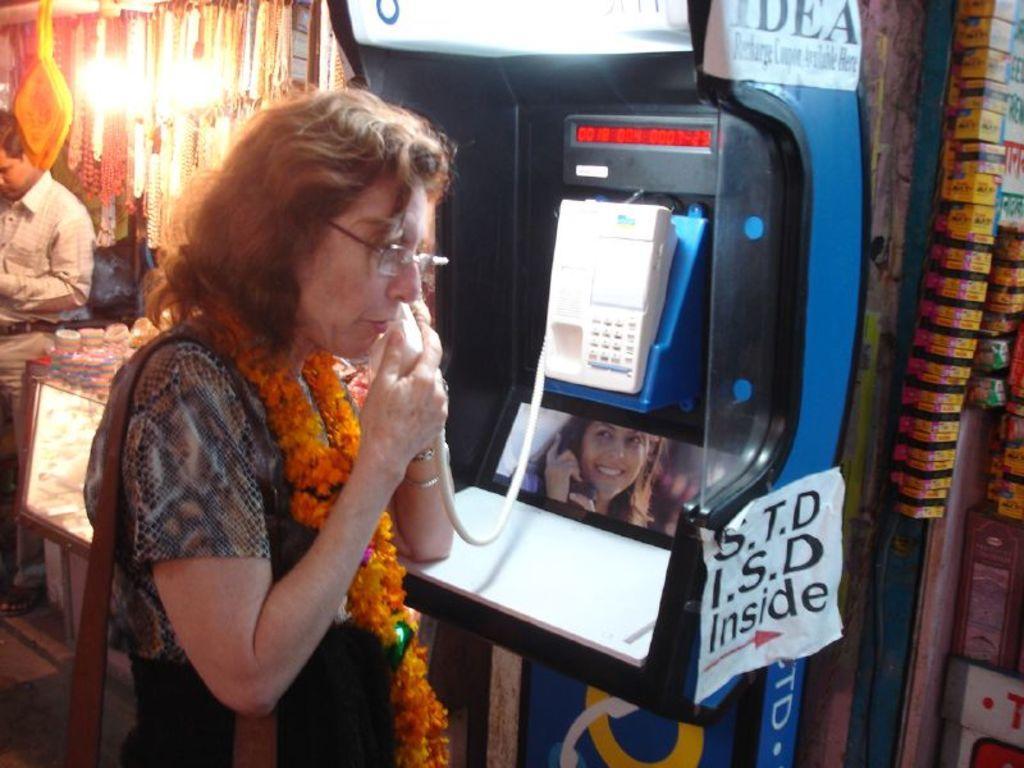Describe this image in one or two sentences. In this image there is a lady holding a bag and talking in a telephone booth, on the either sides of the booth there are stalls and there is a person standing. 